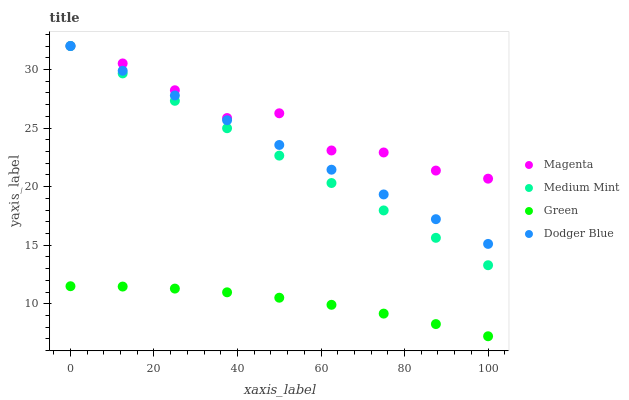Does Green have the minimum area under the curve?
Answer yes or no. Yes. Does Magenta have the maximum area under the curve?
Answer yes or no. Yes. Does Dodger Blue have the minimum area under the curve?
Answer yes or no. No. Does Dodger Blue have the maximum area under the curve?
Answer yes or no. No. Is Dodger Blue the smoothest?
Answer yes or no. Yes. Is Magenta the roughest?
Answer yes or no. Yes. Is Magenta the smoothest?
Answer yes or no. No. Is Dodger Blue the roughest?
Answer yes or no. No. Does Green have the lowest value?
Answer yes or no. Yes. Does Dodger Blue have the lowest value?
Answer yes or no. No. Does Magenta have the highest value?
Answer yes or no. Yes. Does Green have the highest value?
Answer yes or no. No. Is Green less than Magenta?
Answer yes or no. Yes. Is Medium Mint greater than Green?
Answer yes or no. Yes. Does Magenta intersect Medium Mint?
Answer yes or no. Yes. Is Magenta less than Medium Mint?
Answer yes or no. No. Is Magenta greater than Medium Mint?
Answer yes or no. No. Does Green intersect Magenta?
Answer yes or no. No. 